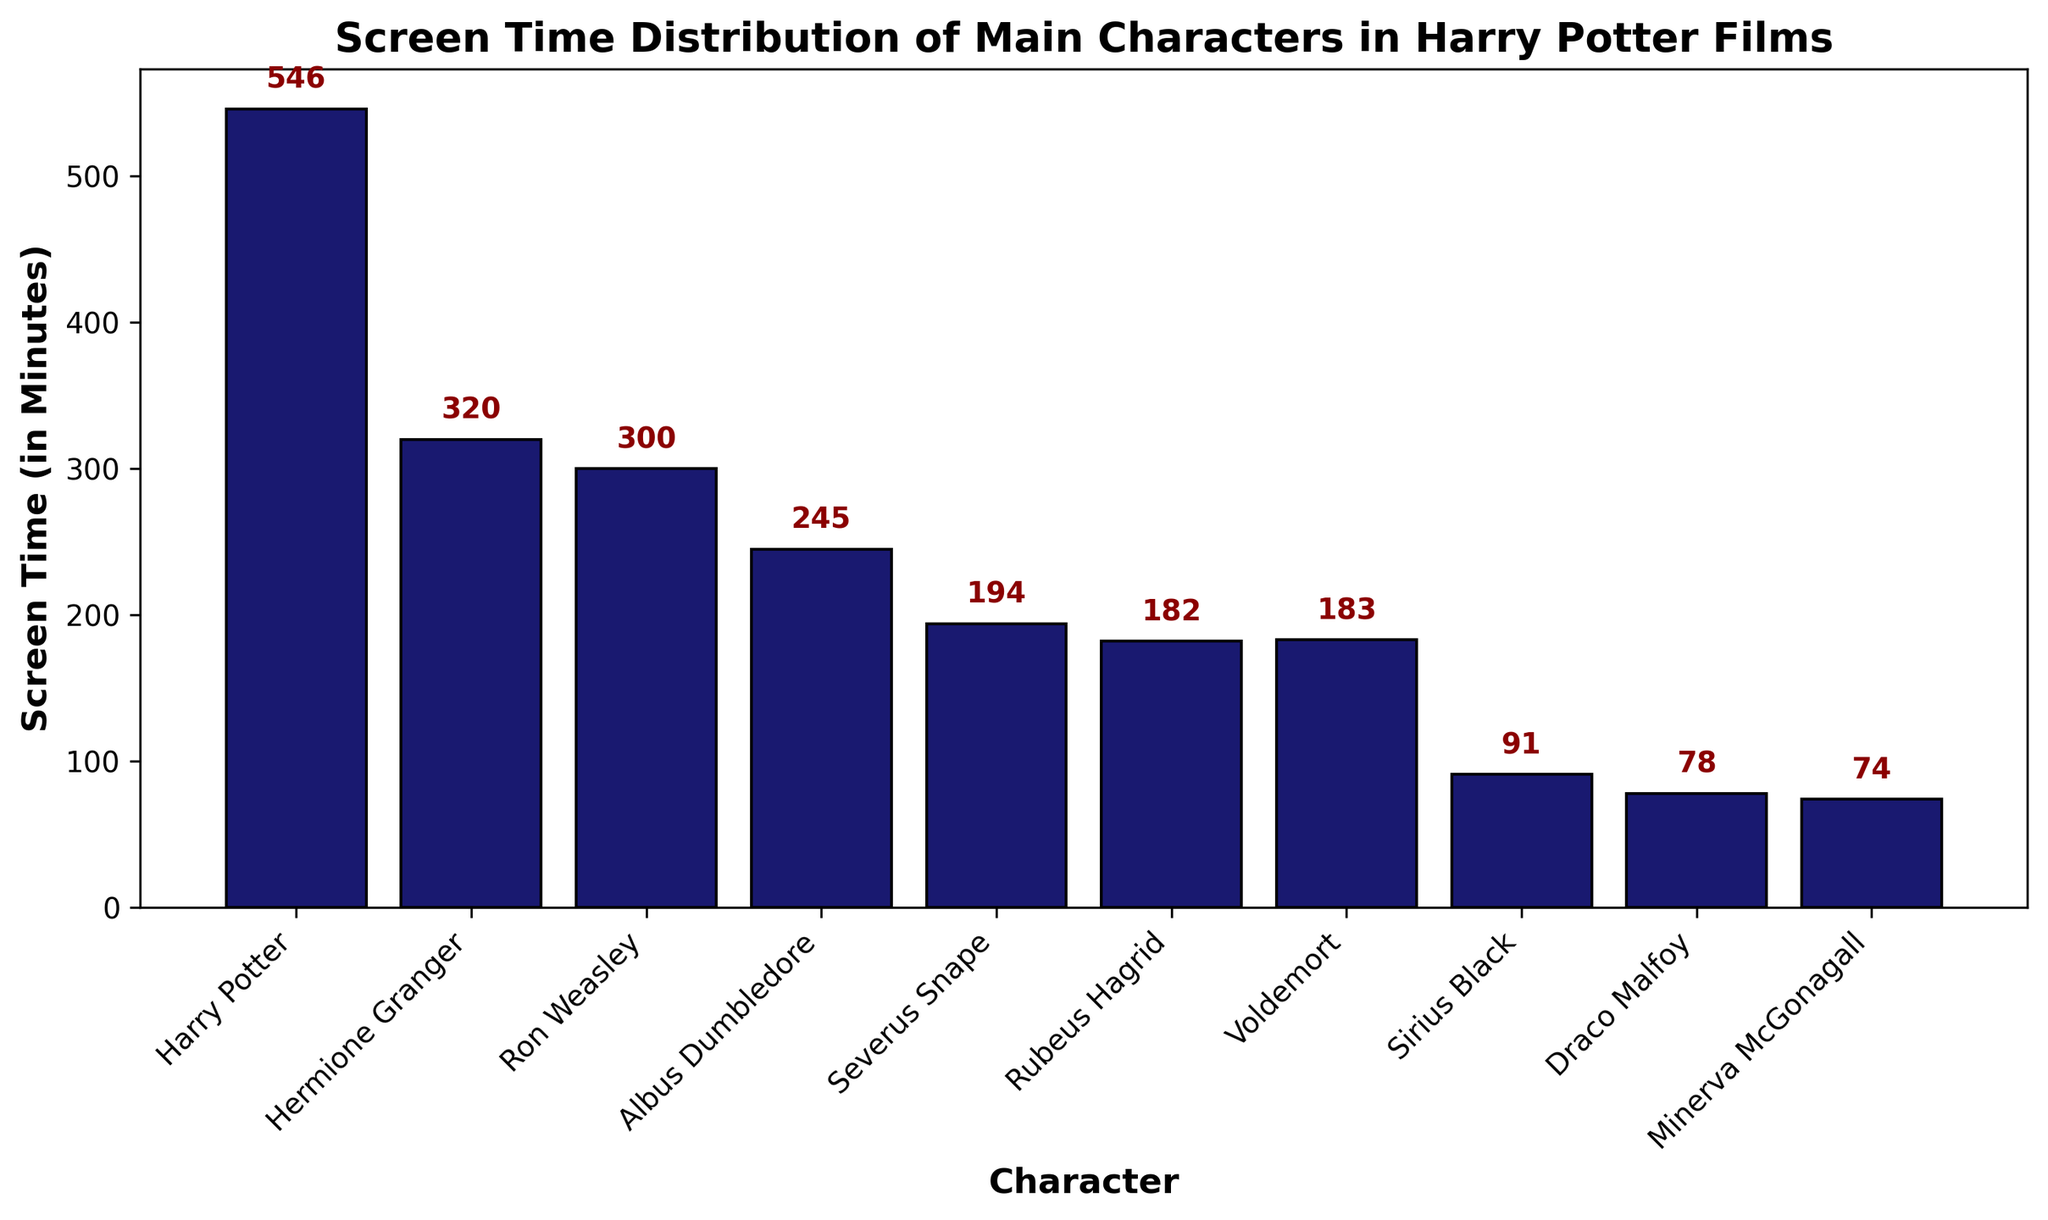Who has the highest screen time in the Harry Potter films? Harry Potter has the highest screen time. By observing the tallest bar on the chart, we can see that Harry Potter's bar is significantly taller than the others, indicating the longest screen time.
Answer: Harry Potter Which character has a slightly longer screen time than Voldemort? By comparing the bars, Voldemort’s screen time is 183 minutes, and the next taller bar is Rubeus Hagrid with 182 minutes screen time. So, Voldemort has a slightly longer screen time than Hagrid, but no other character has slightly longer screen time than Voldemort by just one minute.
Answer: No character What is the total screen time of Harry, Hermione, and Ron? Adding up the screen times of Harry (546 minutes), Hermione (320 minutes), and Ron (300 minutes). The total is 546 + 320 + 300 = 1166 minutes.
Answer: 1166 minutes How much more screen time does Harry Potter have compared to Severus Snape? Subtract Severus Snape’s screen time (194 minutes) from Harry Potter’s screen time (546 minutes). The calculation is 546 - 194 = 352 minutes.
Answer: 352 minutes What is the average screen time of Dumbledore, Snape, and Hagrid? Add up their screen times: Dumbledore (245), Snape (194), and Hagrid (182). The total is 245 + 194 + 182 = 621 minutes. Then, divide by the number of characters, which is 3: 621 / 3 = 207 minutes.
Answer: 207 minutes Which two characters have the least screen time and what is their combined screen time? The two characters with the shortest bars are Draco Malfoy (78 minutes) and Minerva McGonagall (74 minutes). Their combined screen time is 78 + 74 = 152 minutes.
Answer: Draco Malfoy and Minerva McGonagall, 152 minutes Is Voldemort’s screen time greater or lesser than Rubeus Hagrid’s? Comparing the heights of Voldemort’s and Rubeus Hagrid’s bars, Voldemort’s screen time is slightly more at 183 minutes, while Hagrid’s is 182 minutes.
Answer: Greater What is the difference in screen time between Sirius Black and Draco Malfoy? Subtract Draco Malfoy’s screen time (78 minutes) from Sirius Black’s screen time (91 minutes). The calculation is 91 - 78 = 13 minutes.
Answer: 13 minutes What is the total screen time of all characters who have more than 200 minutes of screen time? Identify characters with more than 200 minutes: Harry (546), Hermione (320), Ron (300), and Dumbledore (245). Adding these up: 546 + 320 + 300 + 245 = 1411 minutes.
Answer: 1411 minutes Of the main characters listed, who has the second least amount of screen time? By observing the heights of the bars, Minerva McGonagall has the shortest screen time, and the second shortest is Draco Malfoy with 78 minutes.
Answer: Draco Malfoy 